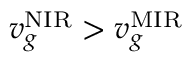Convert formula to latex. <formula><loc_0><loc_0><loc_500><loc_500>v _ { g } ^ { N I R } > v _ { g } ^ { M I R }</formula> 